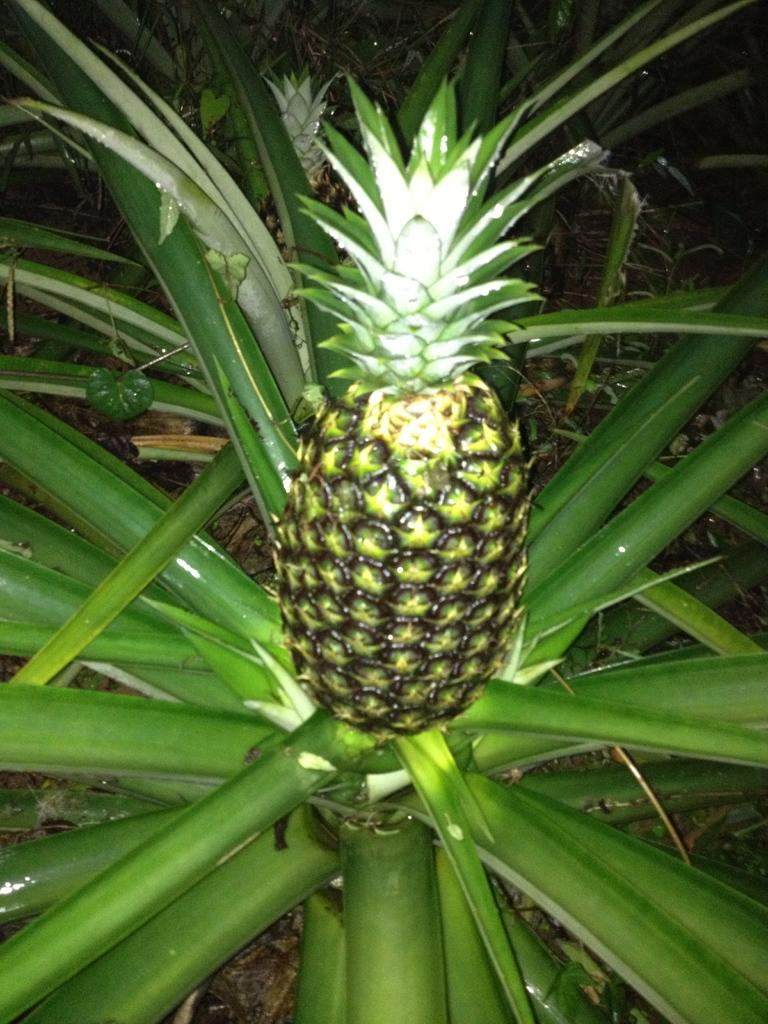What type of plant is in the image? There is a pineapple plant in the image. What can be observed about the background of the image? The background of the image is dark. How many candles are on the birthday cake in the image? There is no birthday cake or candles present in the image; it features a pineapple plant with a dark background. 